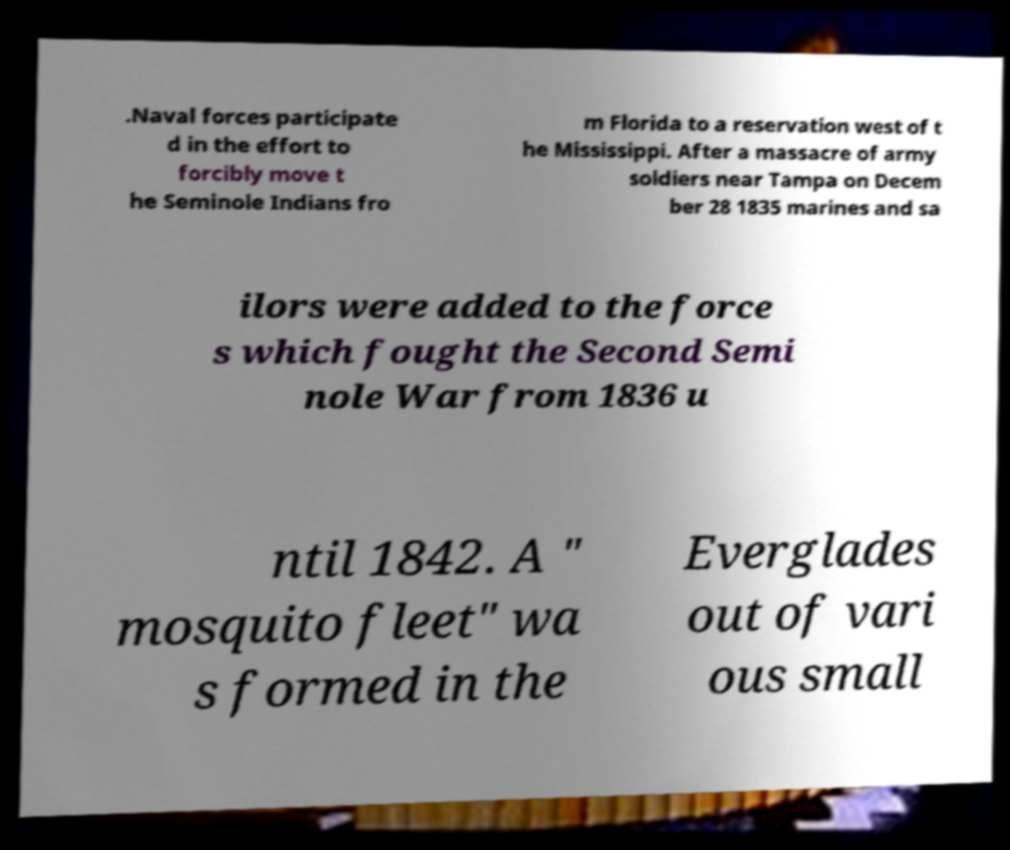Can you accurately transcribe the text from the provided image for me? .Naval forces participate d in the effort to forcibly move t he Seminole Indians fro m Florida to a reservation west of t he Mississippi. After a massacre of army soldiers near Tampa on Decem ber 28 1835 marines and sa ilors were added to the force s which fought the Second Semi nole War from 1836 u ntil 1842. A " mosquito fleet" wa s formed in the Everglades out of vari ous small 